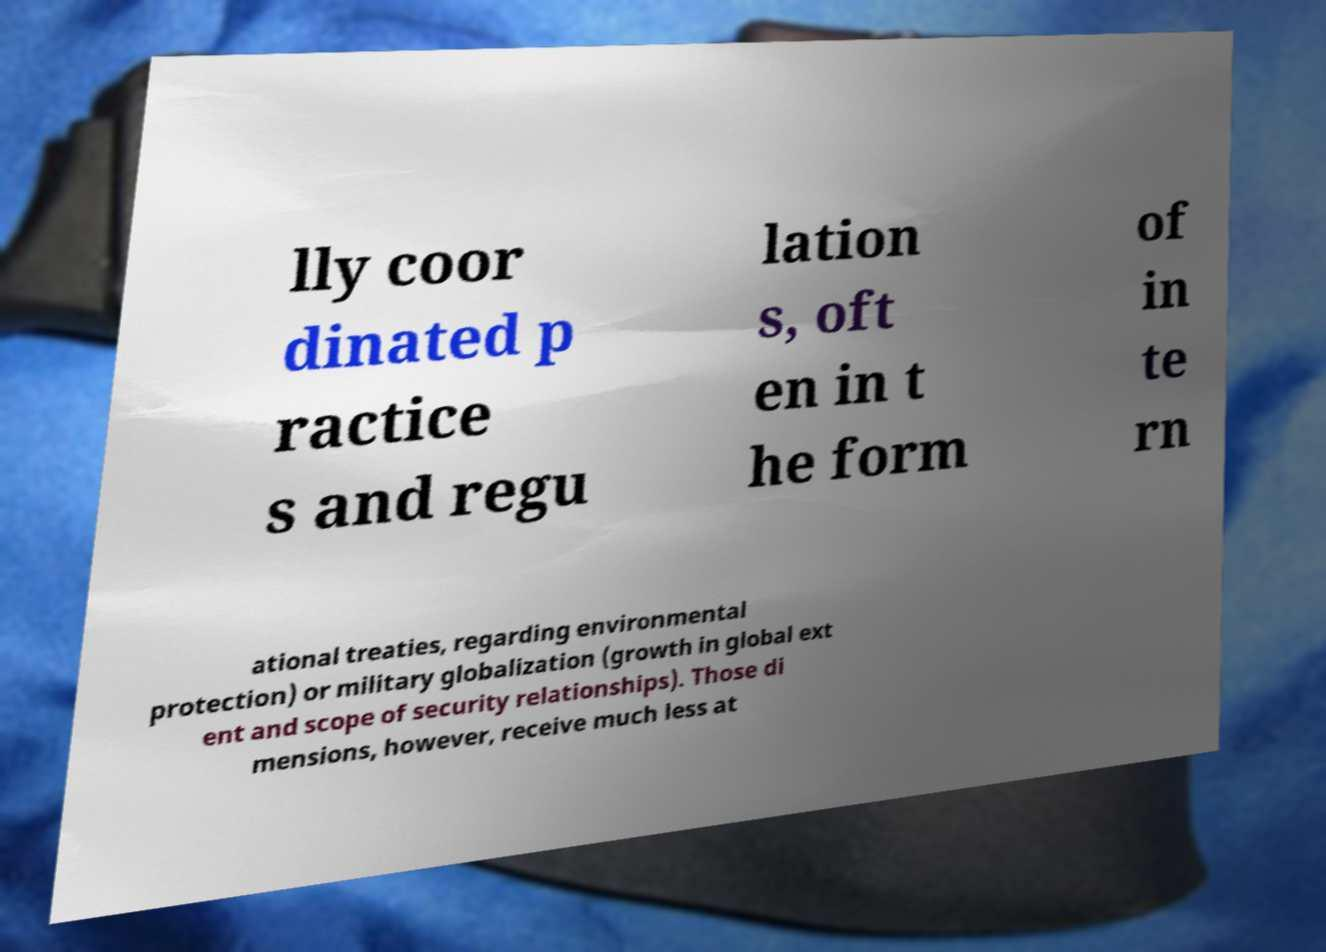Please read and relay the text visible in this image. What does it say? lly coor dinated p ractice s and regu lation s, oft en in t he form of in te rn ational treaties, regarding environmental protection) or military globalization (growth in global ext ent and scope of security relationships). Those di mensions, however, receive much less at 